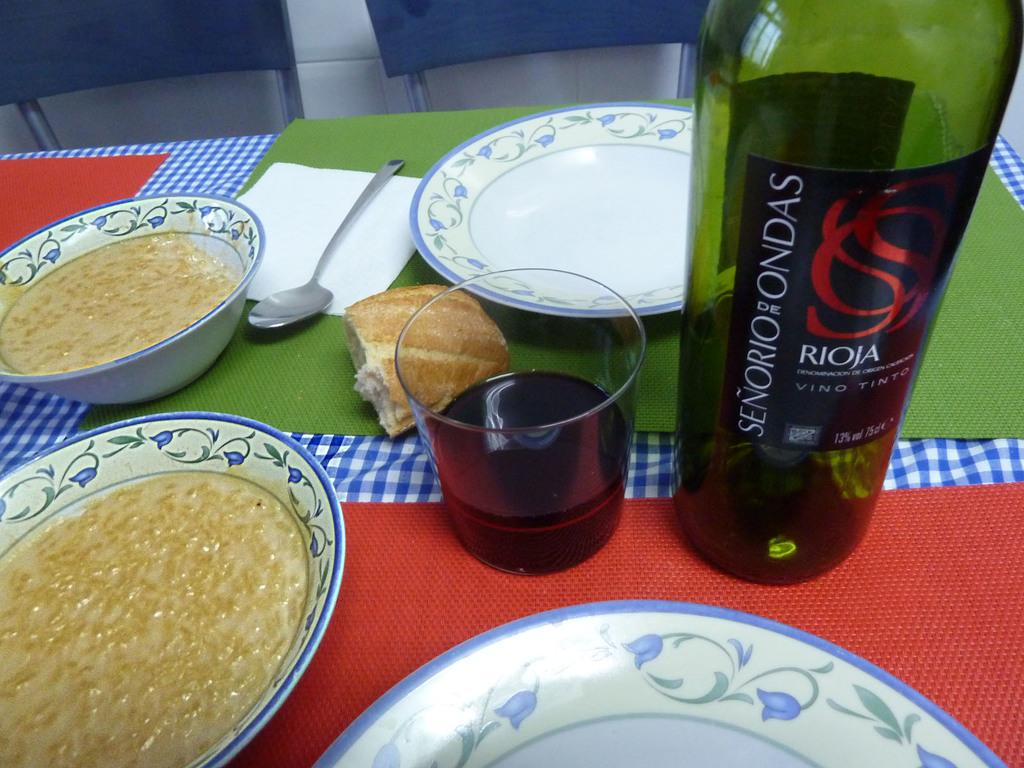<image>
Share a concise interpretation of the image provided. A colorful table with a bottle of red wine from Senerio de Ondas. 